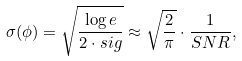Convert formula to latex. <formula><loc_0><loc_0><loc_500><loc_500>\sigma ( \phi ) = \sqrt { \frac { \log e } { 2 \cdot s i g } } \approx \sqrt { \frac { 2 } { \pi } } \cdot \frac { 1 } { S N R } ,</formula> 